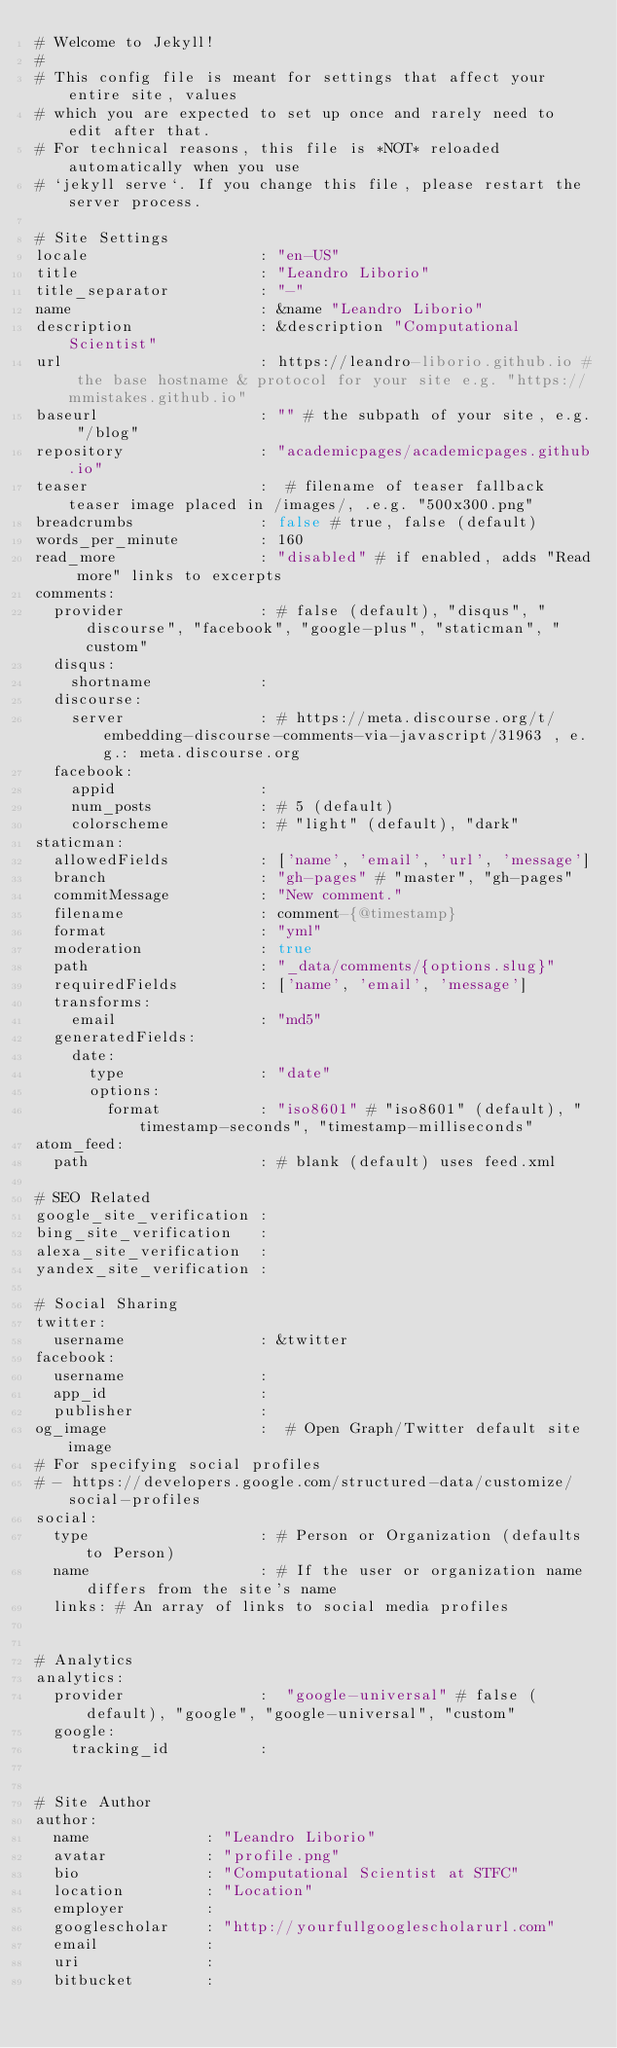Convert code to text. <code><loc_0><loc_0><loc_500><loc_500><_YAML_># Welcome to Jekyll!
#
# This config file is meant for settings that affect your entire site, values
# which you are expected to set up once and rarely need to edit after that.
# For technical reasons, this file is *NOT* reloaded automatically when you use
# `jekyll serve`. If you change this file, please restart the server process.

# Site Settings
locale                   : "en-US"
title                    : "Leandro Liborio"
title_separator          : "-"
name                     : &name "Leandro Liborio"
description              : &description "Computational Scientist"
url                      : https://leandro-liborio.github.io # the base hostname & protocol for your site e.g. "https://mmistakes.github.io"
baseurl                  : "" # the subpath of your site, e.g. "/blog"
repository               : "academicpages/academicpages.github.io"
teaser                   :  # filename of teaser fallback teaser image placed in /images/, .e.g. "500x300.png"
breadcrumbs              : false # true, false (default)
words_per_minute         : 160
read_more                : "disabled" # if enabled, adds "Read more" links to excerpts
comments:
  provider               : # false (default), "disqus", "discourse", "facebook", "google-plus", "staticman", "custom"
  disqus:
    shortname            :
  discourse:
    server               : # https://meta.discourse.org/t/embedding-discourse-comments-via-javascript/31963 , e.g.: meta.discourse.org
  facebook:
    appid                :
    num_posts            : # 5 (default)
    colorscheme          : # "light" (default), "dark"
staticman:
  allowedFields          : ['name', 'email', 'url', 'message']
  branch                 : "gh-pages" # "master", "gh-pages"
  commitMessage          : "New comment."
  filename               : comment-{@timestamp}
  format                 : "yml"
  moderation             : true
  path                   : "_data/comments/{options.slug}"
  requiredFields         : ['name', 'email', 'message']
  transforms:
    email                : "md5"
  generatedFields:
    date:
      type               : "date"
      options:
        format           : "iso8601" # "iso8601" (default), "timestamp-seconds", "timestamp-milliseconds"
atom_feed:
  path                   : # blank (default) uses feed.xml

# SEO Related
google_site_verification :
bing_site_verification   :
alexa_site_verification  :
yandex_site_verification :

# Social Sharing
twitter:
  username               : &twitter
facebook:
  username               :
  app_id                 :
  publisher              :
og_image                 :  # Open Graph/Twitter default site image
# For specifying social profiles
# - https://developers.google.com/structured-data/customize/social-profiles
social:
  type                   : # Person or Organization (defaults to Person)
  name                   : # If the user or organization name differs from the site's name
  links: # An array of links to social media profiles


# Analytics
analytics:
  provider               :  "google-universal" # false (default), "google", "google-universal", "custom"
  google:
    tracking_id          :


# Site Author
author:
  name             : "Leandro Liborio"
  avatar           : "profile.png"
  bio              : "Computational Scientist at STFC"
  location         : "Location"
  employer         :
  googlescholar    : "http://yourfullgooglescholarurl.com"
  email            :
  uri              :
  bitbucket        :</code> 